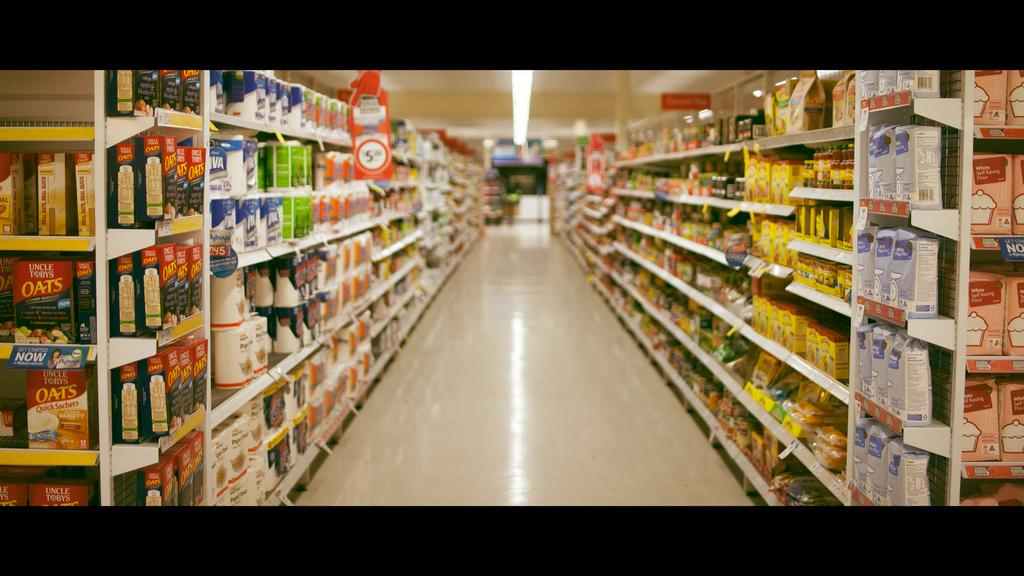What type of furniture is visible in the image? There are shelves in the image. What can be found on the shelves? Objects are present on the shelves. What type of lighting is visible in the image? There are lights on the ceiling in the image. What type of belief is represented by the hen and snakes in the image? There are no hen or snakes present in the image, so it is not possible to determine any beliefs represented by them. 